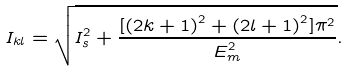Convert formula to latex. <formula><loc_0><loc_0><loc_500><loc_500>I _ { k l } = \sqrt { I _ { s } ^ { 2 } + \frac { [ \left ( 2 k + 1 \right ) ^ { 2 } + \left ( 2 l + 1 \right ) ^ { 2 } ] \pi ^ { 2 } } { E _ { m } ^ { 2 } } } .</formula> 